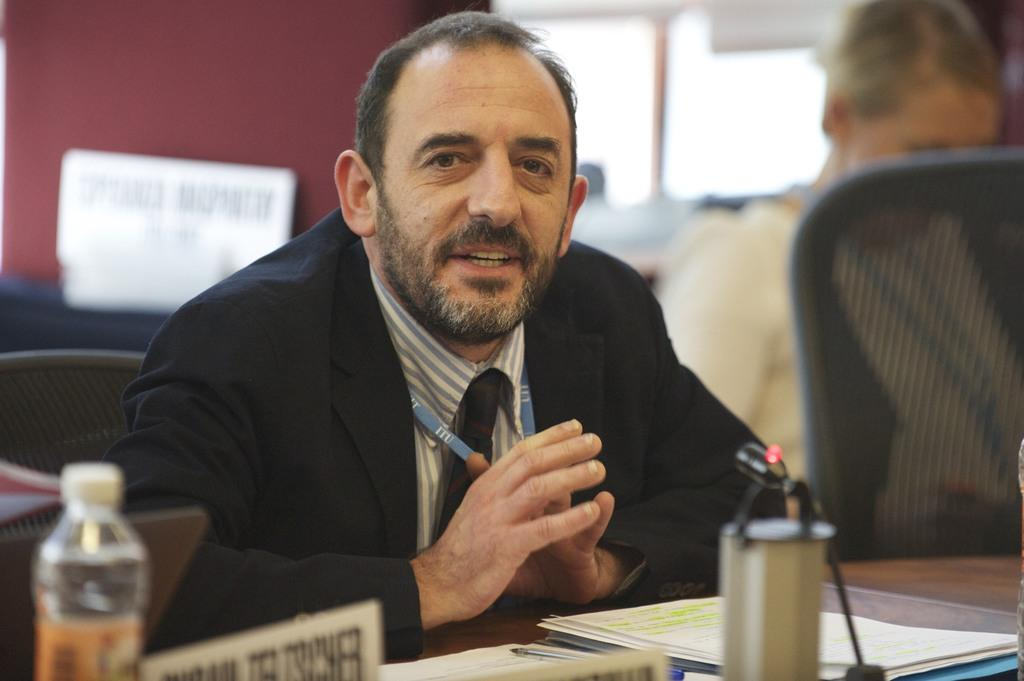Who is present in the image? There is a man in the image. What is the man wearing? The man is wearing a black suit. What can be seen on the table in the image? There are papers and a bottle on the table. What type of furniture is in the image? There is a table and a chair in the image. What type of cast does the man have on his arm in the image? There is no cast visible on the man's arm in the image. How many matches are on the table in the image? There are no matches present on the table in the image. 